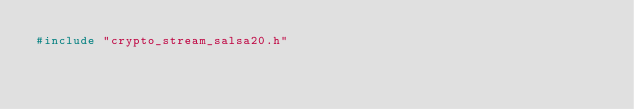<code> <loc_0><loc_0><loc_500><loc_500><_C_>#include "crypto_stream_salsa20.h"
</code> 